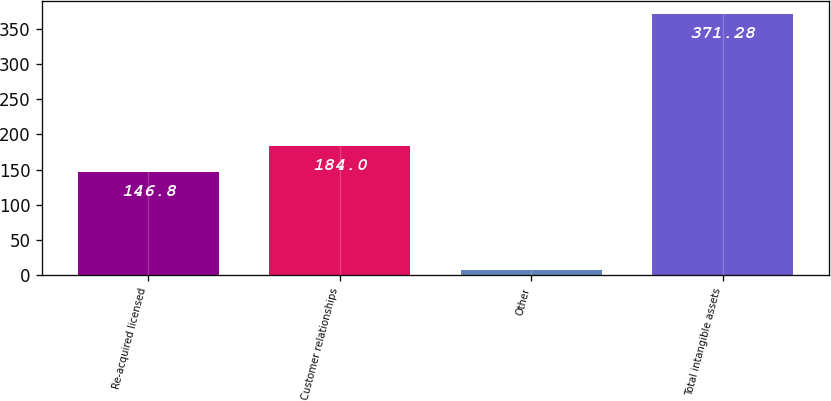Convert chart. <chart><loc_0><loc_0><loc_500><loc_500><bar_chart><fcel>Re-acquired licensed<fcel>Customer relationships<fcel>Other<fcel>Total intangible assets<nl><fcel>146.8<fcel>184<fcel>7.4<fcel>371.28<nl></chart> 